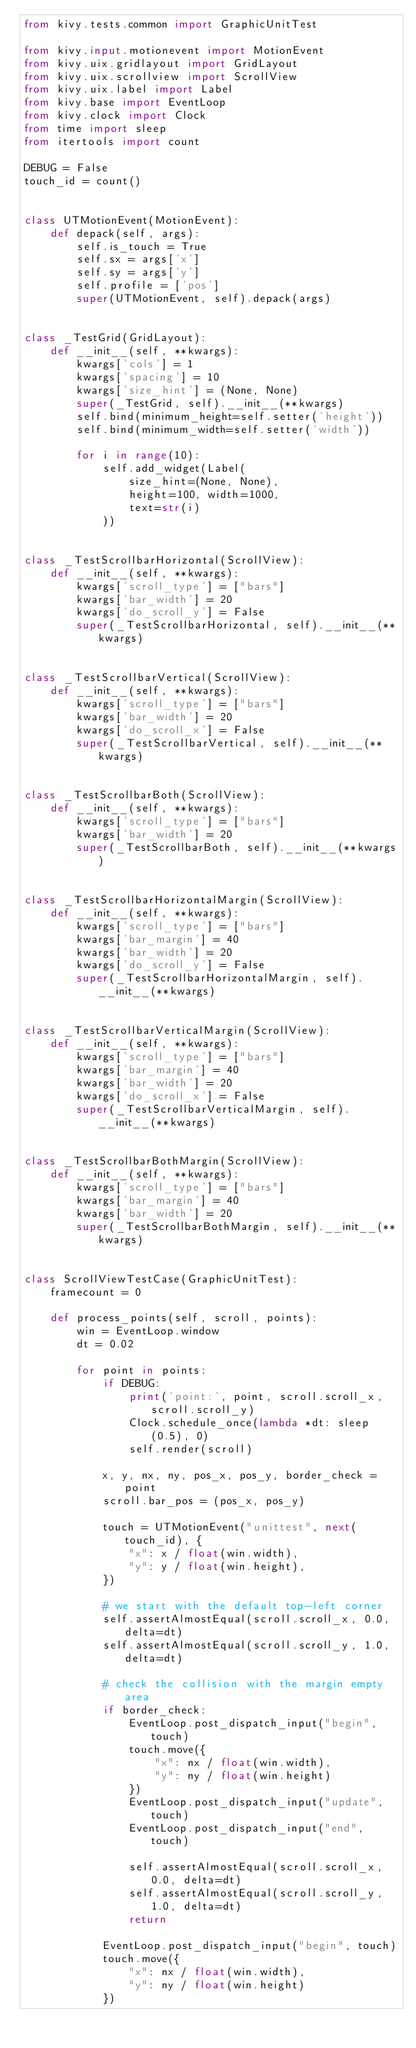<code> <loc_0><loc_0><loc_500><loc_500><_Python_>from kivy.tests.common import GraphicUnitTest

from kivy.input.motionevent import MotionEvent
from kivy.uix.gridlayout import GridLayout
from kivy.uix.scrollview import ScrollView
from kivy.uix.label import Label
from kivy.base import EventLoop
from kivy.clock import Clock
from time import sleep
from itertools import count

DEBUG = False
touch_id = count()


class UTMotionEvent(MotionEvent):
    def depack(self, args):
        self.is_touch = True
        self.sx = args['x']
        self.sy = args['y']
        self.profile = ['pos']
        super(UTMotionEvent, self).depack(args)


class _TestGrid(GridLayout):
    def __init__(self, **kwargs):
        kwargs['cols'] = 1
        kwargs['spacing'] = 10
        kwargs['size_hint'] = (None, None)
        super(_TestGrid, self).__init__(**kwargs)
        self.bind(minimum_height=self.setter('height'))
        self.bind(minimum_width=self.setter('width'))

        for i in range(10):
            self.add_widget(Label(
                size_hint=(None, None),
                height=100, width=1000,
                text=str(i)
            ))


class _TestScrollbarHorizontal(ScrollView):
    def __init__(self, **kwargs):
        kwargs['scroll_type'] = ["bars"]
        kwargs['bar_width'] = 20
        kwargs['do_scroll_y'] = False
        super(_TestScrollbarHorizontal, self).__init__(**kwargs)


class _TestScrollbarVertical(ScrollView):
    def __init__(self, **kwargs):
        kwargs['scroll_type'] = ["bars"]
        kwargs['bar_width'] = 20
        kwargs['do_scroll_x'] = False
        super(_TestScrollbarVertical, self).__init__(**kwargs)


class _TestScrollbarBoth(ScrollView):
    def __init__(self, **kwargs):
        kwargs['scroll_type'] = ["bars"]
        kwargs['bar_width'] = 20
        super(_TestScrollbarBoth, self).__init__(**kwargs)


class _TestScrollbarHorizontalMargin(ScrollView):
    def __init__(self, **kwargs):
        kwargs['scroll_type'] = ["bars"]
        kwargs['bar_margin'] = 40
        kwargs['bar_width'] = 20
        kwargs['do_scroll_y'] = False
        super(_TestScrollbarHorizontalMargin, self).__init__(**kwargs)


class _TestScrollbarVerticalMargin(ScrollView):
    def __init__(self, **kwargs):
        kwargs['scroll_type'] = ["bars"]
        kwargs['bar_margin'] = 40
        kwargs['bar_width'] = 20
        kwargs['do_scroll_x'] = False
        super(_TestScrollbarVerticalMargin, self).__init__(**kwargs)


class _TestScrollbarBothMargin(ScrollView):
    def __init__(self, **kwargs):
        kwargs['scroll_type'] = ["bars"]
        kwargs['bar_margin'] = 40
        kwargs['bar_width'] = 20
        super(_TestScrollbarBothMargin, self).__init__(**kwargs)


class ScrollViewTestCase(GraphicUnitTest):
    framecount = 0

    def process_points(self, scroll, points):
        win = EventLoop.window
        dt = 0.02

        for point in points:
            if DEBUG:
                print('point:', point, scroll.scroll_x, scroll.scroll_y)
                Clock.schedule_once(lambda *dt: sleep(0.5), 0)
                self.render(scroll)

            x, y, nx, ny, pos_x, pos_y, border_check = point
            scroll.bar_pos = (pos_x, pos_y)

            touch = UTMotionEvent("unittest", next(touch_id), {
                "x": x / float(win.width),
                "y": y / float(win.height),
            })

            # we start with the default top-left corner
            self.assertAlmostEqual(scroll.scroll_x, 0.0, delta=dt)
            self.assertAlmostEqual(scroll.scroll_y, 1.0, delta=dt)

            # check the collision with the margin empty area
            if border_check:
                EventLoop.post_dispatch_input("begin", touch)
                touch.move({
                    "x": nx / float(win.width),
                    "y": ny / float(win.height)
                })
                EventLoop.post_dispatch_input("update", touch)
                EventLoop.post_dispatch_input("end", touch)

                self.assertAlmostEqual(scroll.scroll_x, 0.0, delta=dt)
                self.assertAlmostEqual(scroll.scroll_y, 1.0, delta=dt)
                return

            EventLoop.post_dispatch_input("begin", touch)
            touch.move({
                "x": nx / float(win.width),
                "y": ny / float(win.height)
            })</code> 